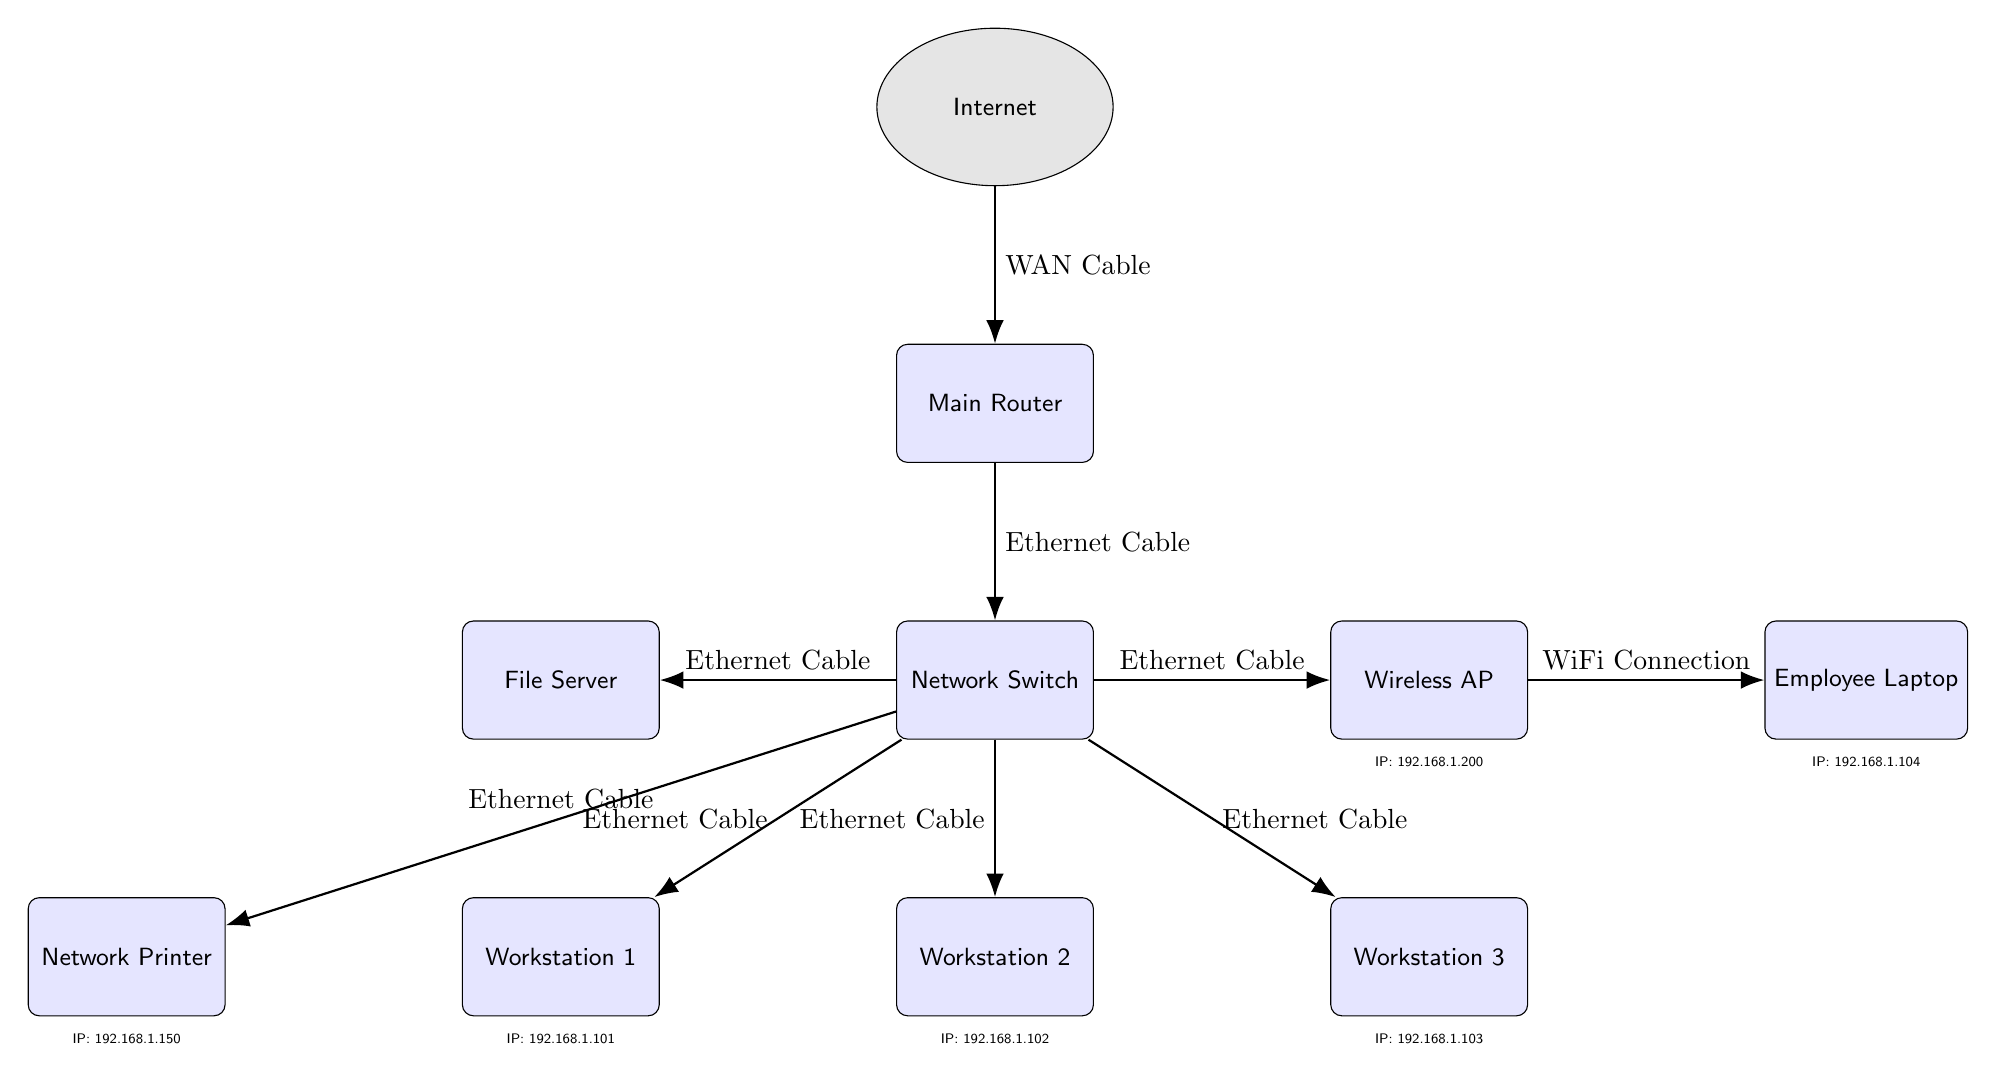What is the IP address of Workstation 1? By examining the label directly below Workstation 1 in the diagram, we can see that it states "IP: 192.168.1.101."
Answer: 192.168.1.101 How many devices are connected to the Network Switch? Counting the devices that are depicted as being connected to the Network Switch, which includes the File Server, Wireless AP, Workstation 1, Workstation 2, Workstation 3, and Network Printer, totals six devices connected directly.
Answer: 6 What type of connection does the Wireless AP have with the Employee Laptop? The diagram indicates that the connection type between the Wireless AP and the Employee Laptop is labeled as a "WiFi Connection."
Answer: WiFi Connection Which device has the IP address of 192.168.1.200? Looking directly at the label beneath the Wireless AP, it lists "IP: 192.168.1.200." Therefore, the device with this IP address is the Wireless AP.
Answer: Wireless AP What type of cable connects the Main Router to the Network Switch? The diagram specifies that the connection between the Main Router and the Network Switch is labeled "Ethernet Cable."
Answer: Ethernet Cable Which device is connected to the File Server? The diagram shows that the File Server is directly connected to the Network Switch, indicating it doesn't connect to any other device aside from the switch in this diagram. Thus, the answer would be the Network Switch itself, as it serves as the intermediary.
Answer: Network Switch How many workstations are part of the network? The diagram identifies three distinct workstations labeled as Workstation 1, Workstation 2, and Workstation 3, leading to a total count of three workstations in the network setup.
Answer: 3 Which device has the lowest IP address? By comparing all the listed IP addresses in the diagram, the lowest IP address is 192.168.1.101, belonging to Workstation 1, making it the device with the lowest IP address.
Answer: Workstation 1 